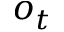<formula> <loc_0><loc_0><loc_500><loc_500>o _ { t }</formula> 